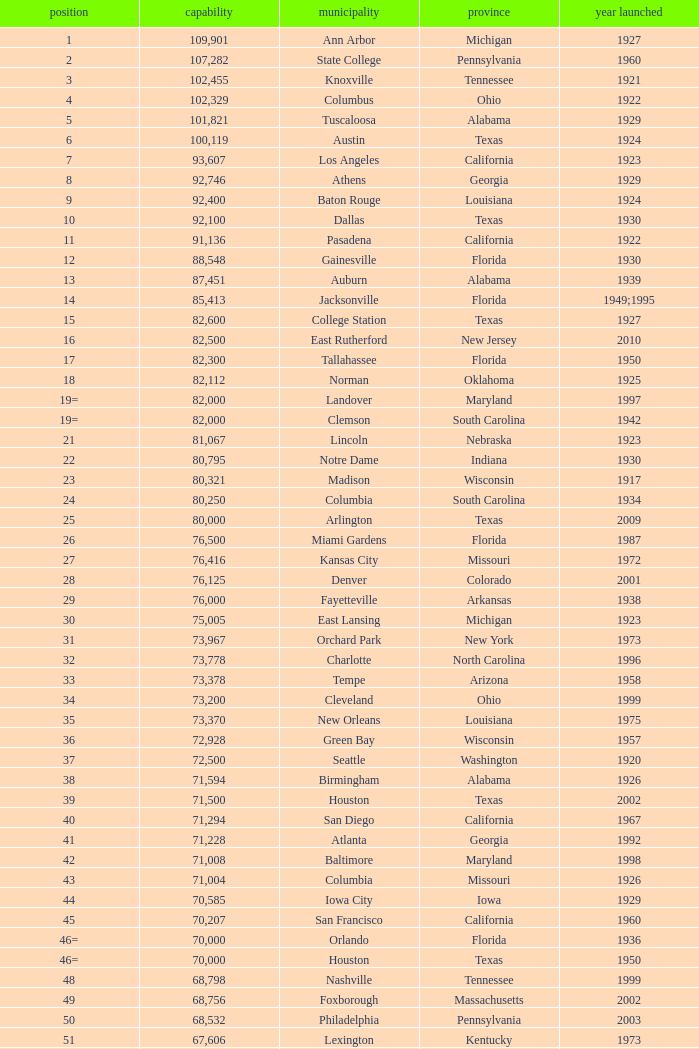What was the year opened for North Carolina with a smaller than 21,500 capacity? 1926.0. 